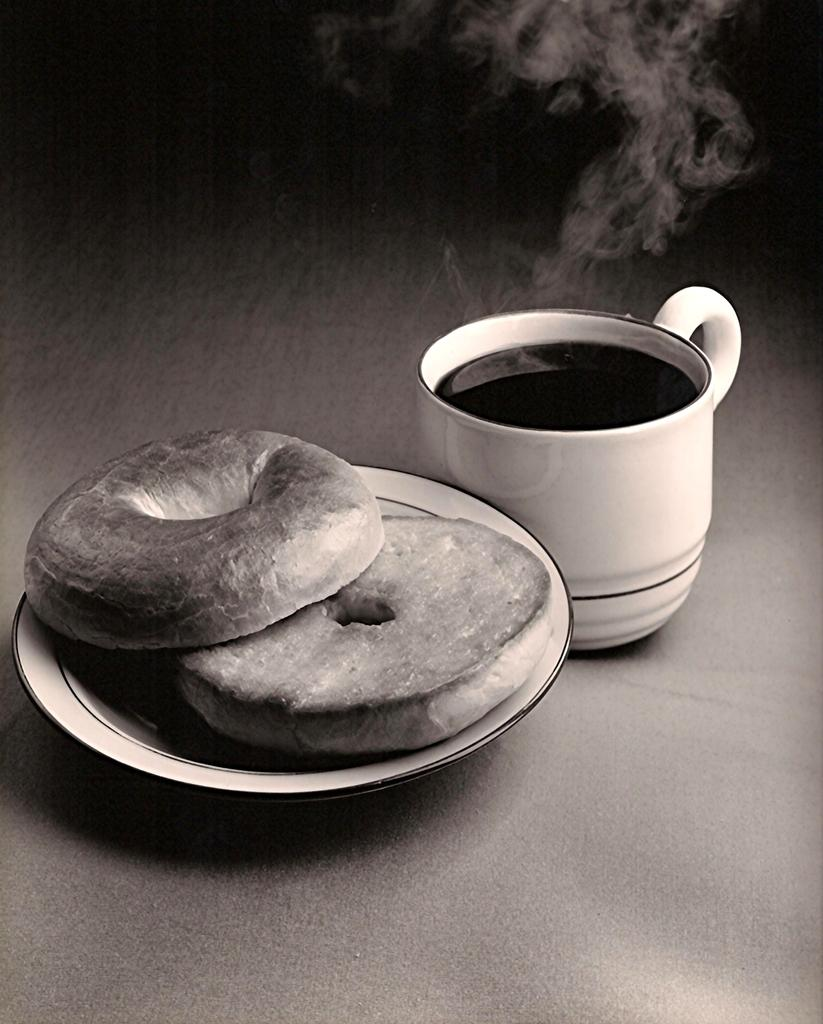What is the color scheme of the image? The image is black and white. What type of beverage is in the cup in the image? The specific type of beverage is not mentioned, but there is a cup of beverage in the image. What food item is present in the image? There are doughnuts in the image. How are the doughnuts arranged in the image? The doughnuts are in a serving plate in the image. How many trains are visible in the image? There are no trains visible in the image; it features a cup of beverage and doughnuts in a serving plate. What type of sock is being worn by the family in the image? There is no family or sock present in the image. 